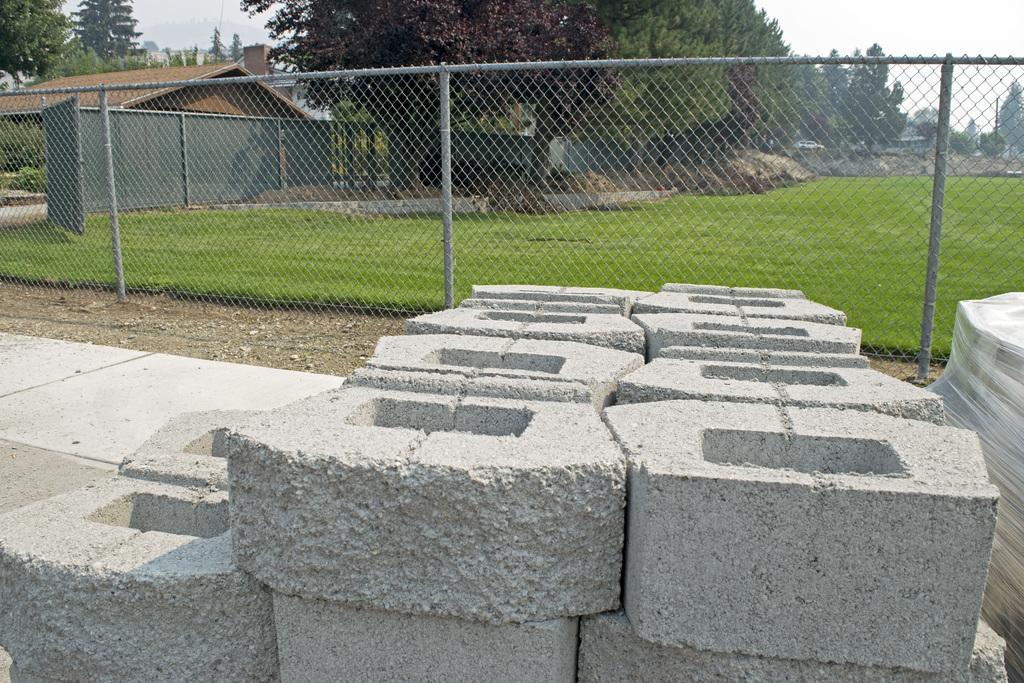How would you summarize this image in a sentence or two? In this picture there are stones at the bottom side of the image and there is net, grassland, trees, and houses in the background area of the image. 